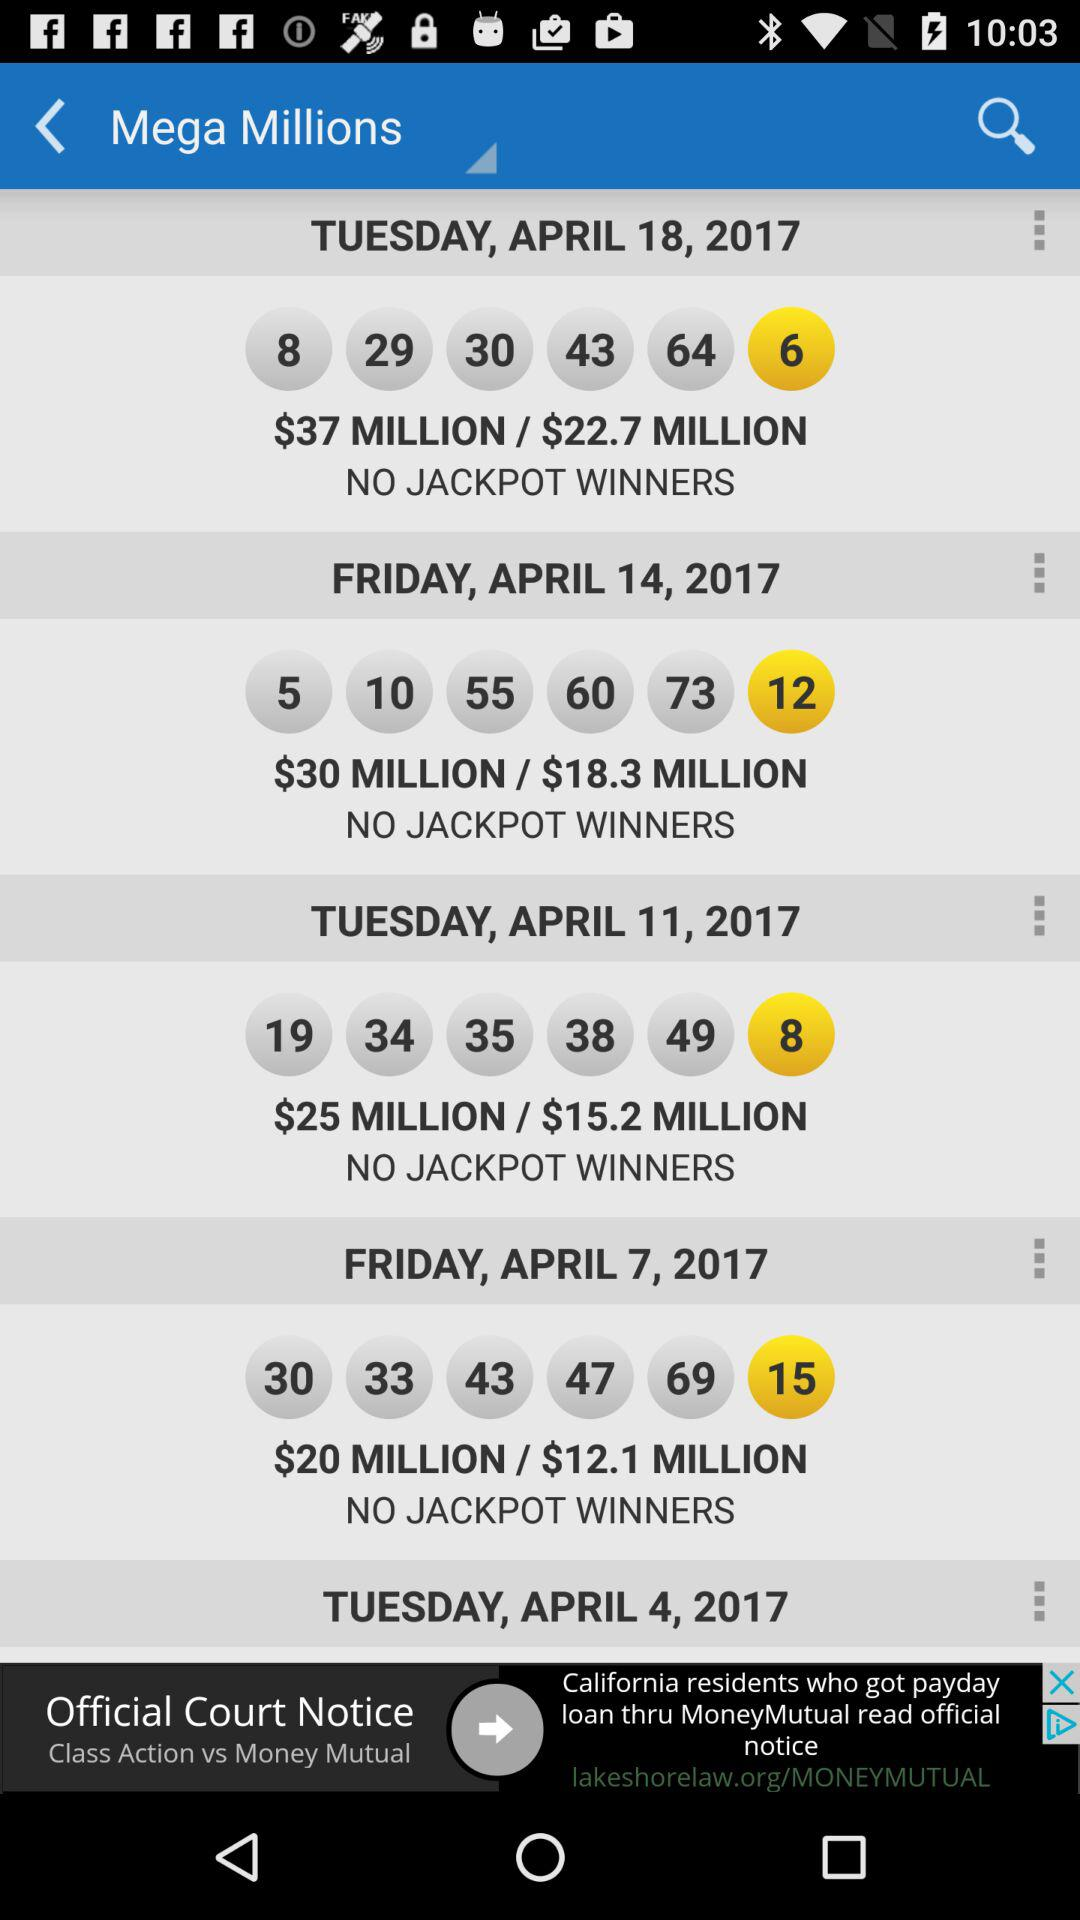How many drawings have no jackpot winners?
Answer the question using a single word or phrase. 4 